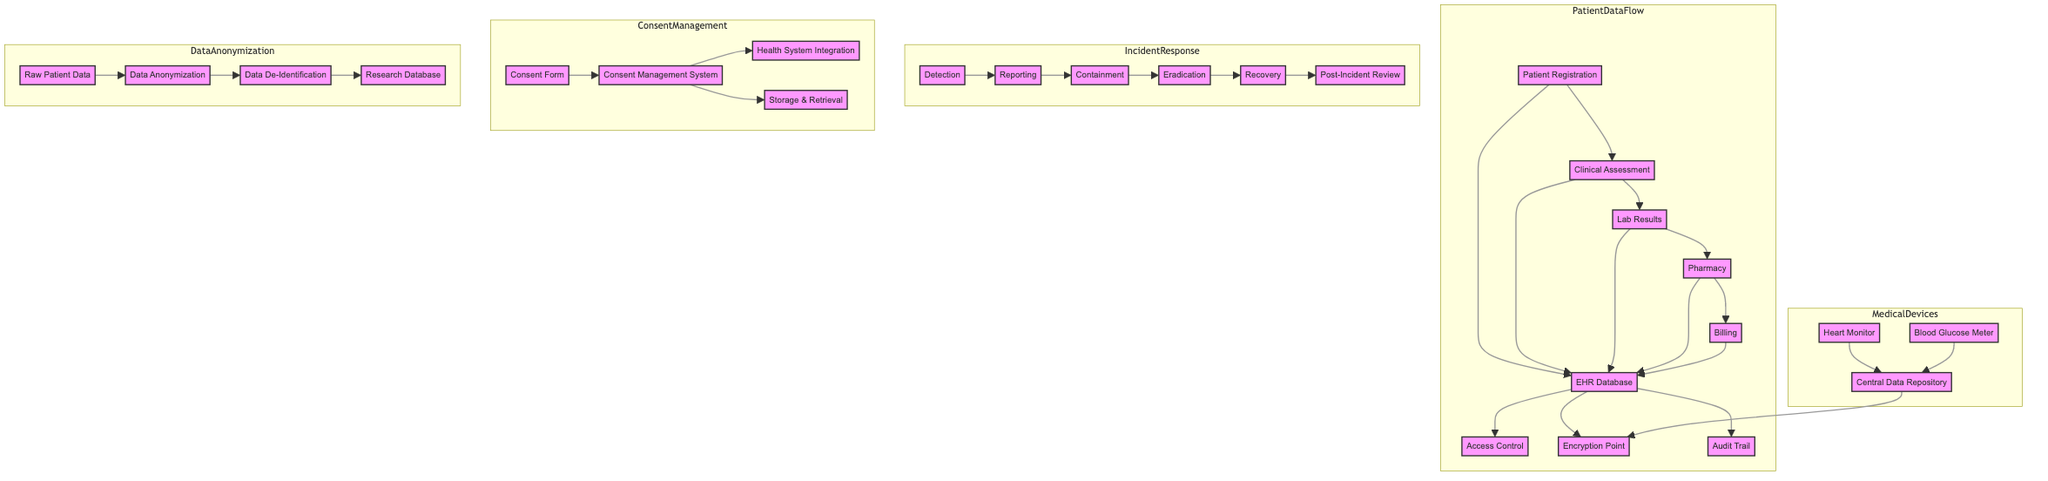What are the main steps of patient data flow? The diagram outlines the flow of patient data from Patient Registration to Clinical Assessment, then to Lab Results, Pharmacy, and finally to Billing. This series of steps represents the basic workflow in patient data processing.
Answer: Patient Registration, Clinical Assessment, Lab Results, Pharmacy, Billing What is the role of the EHR database in this diagram? The EHR database is the central repository where all data from patient registration, assessment, lab results, pharmacy, and billing are consolidated. It also interacts with access controls, encryption points, and audit trails for data protection.
Answer: Central repository How many nodes represent the medical devices in the diagram? There are two medical devices shown in the Medical Devices subgraph: the Heart Monitor and the Blood Glucose Meter. We can count these nodes to answer the question.
Answer: Two What are the initial actions taken in the incident response workflow? The incident response starts with Detection, which is followed by Reporting, and then progresses to Containment, Eradication, and Recovery. This sequence indicates the first three actions taken when a data breach is identified.
Answer: Detection, Reporting, Containment Which components ensure compliance in the patient data flow? The components that ensure compliance in the patient data flow are Access Control, Encryption Point, and Audit Trail. These are designed to protect sensitive patient data in the EHR database.
Answer: Access Control, Encryption Point, Audit Trail What is the final outcome of the data anonymization process? The final outcome of the data anonymization process is the Research Database, which contains anonymized and de-identified data, allowing for analysis while maintaining privacy.
Answer: Research Database How is patient consent managed in the diagram? Patient consent is managed through a process that begins with the Consent Form, which is integrated into the Consent Management System. This system also includes storage and retrieval components as part of its functionality.
Answer: Consent Management System What vulnerability point is indicated in the medical devices section? The diagram indicates that the Central Data Repository is the point of potential vulnerability for secure communication protocols and data encryption techniques associated with medical devices.
Answer: Central Data Repository What role does the Post-Incident Review play in the incident response? The Post-Incident Review is the last step of the incident response workflow, which occurs after Recovery, to evaluate the incident and improve future responses. It is crucial for learning from breaches and preventing future incidents.
Answer: Evaluate and improve future responses 